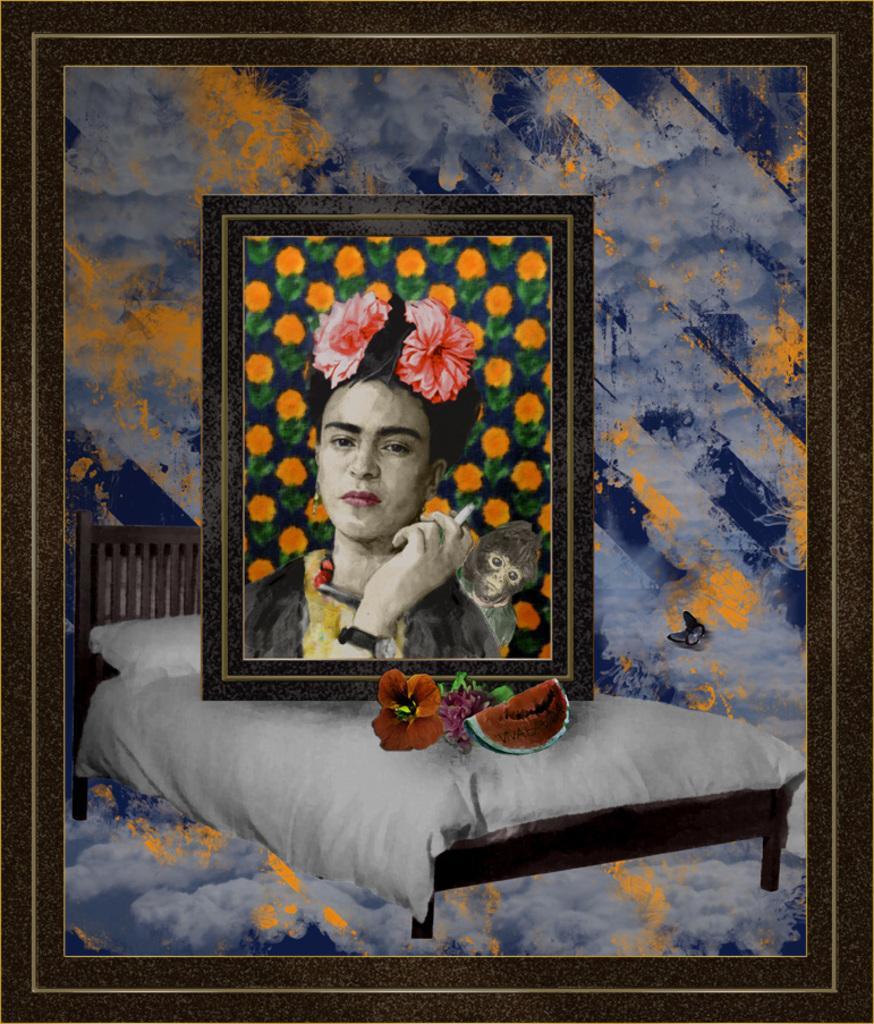In one or two sentences, can you explain what this image depicts? In this image I see a photo frame and I see another frame on it, on which I see the depiction of a woman and an animal on her back and I see the bed and I see few things over here. 